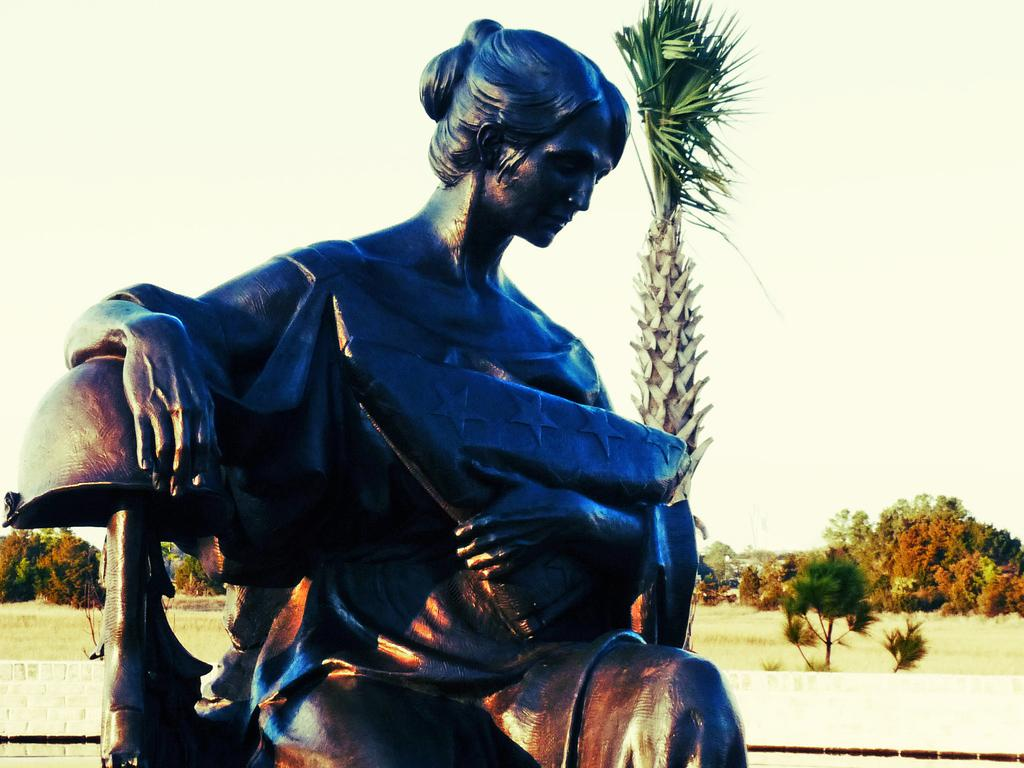What is the main subject of the image? There is a statue of a woman in the image. What is the woman holding in her hand? The woman is holding an object with one hand. What position is the woman in? The woman is sitting. What can be seen in the background of the image? There are trees, grass, and the sky visible in the background of the image. Is the statue sinking into the dirt in the image? There is no dirt present in the image, and the statue is not sinking. Can you tell me how deep the quicksand is around the statue? There is no quicksand present in the image, so it is not possible to determine its depth. 